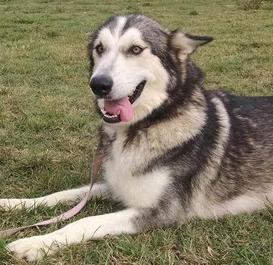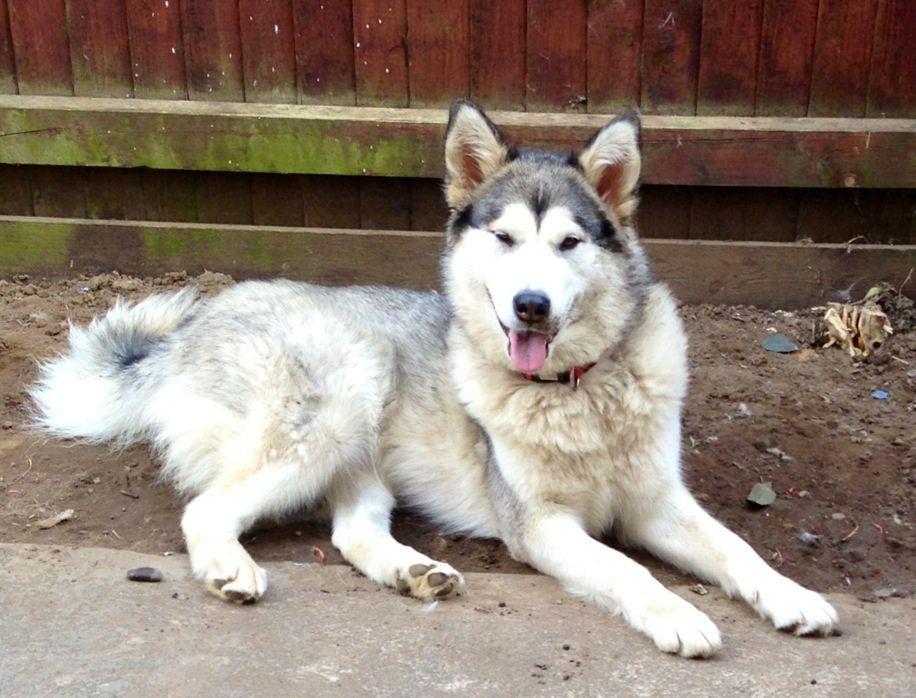The first image is the image on the left, the second image is the image on the right. Evaluate the accuracy of this statement regarding the images: "A dog is standing.". Is it true? Answer yes or no. No. 